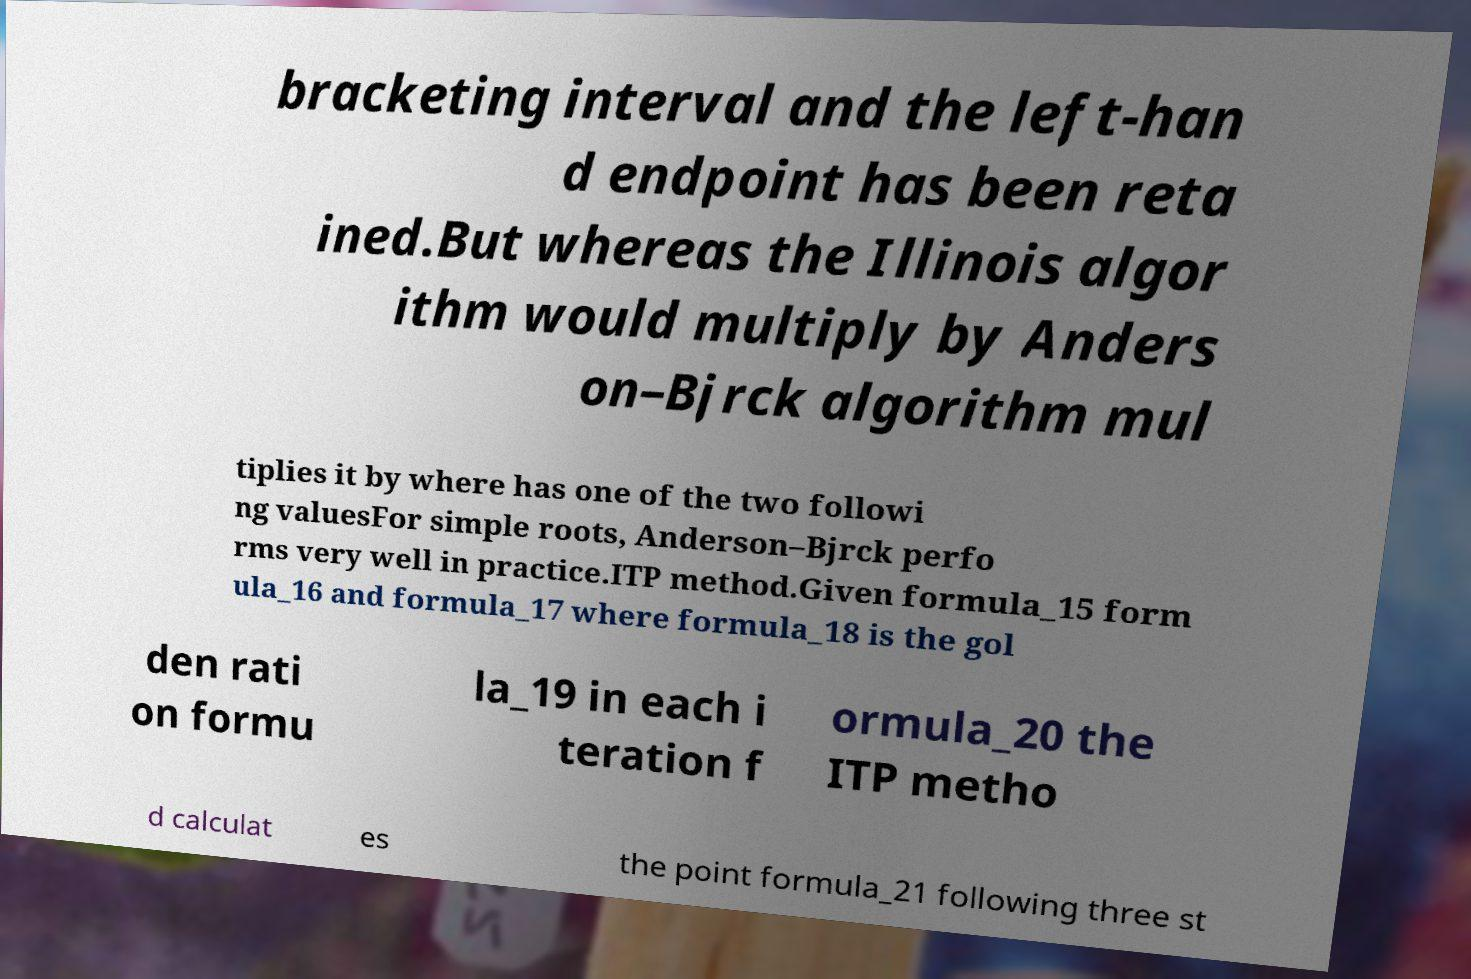I need the written content from this picture converted into text. Can you do that? bracketing interval and the left-han d endpoint has been reta ined.But whereas the Illinois algor ithm would multiply by Anders on–Bjrck algorithm mul tiplies it by where has one of the two followi ng valuesFor simple roots, Anderson–Bjrck perfo rms very well in practice.ITP method.Given formula_15 form ula_16 and formula_17 where formula_18 is the gol den rati on formu la_19 in each i teration f ormula_20 the ITP metho d calculat es the point formula_21 following three st 